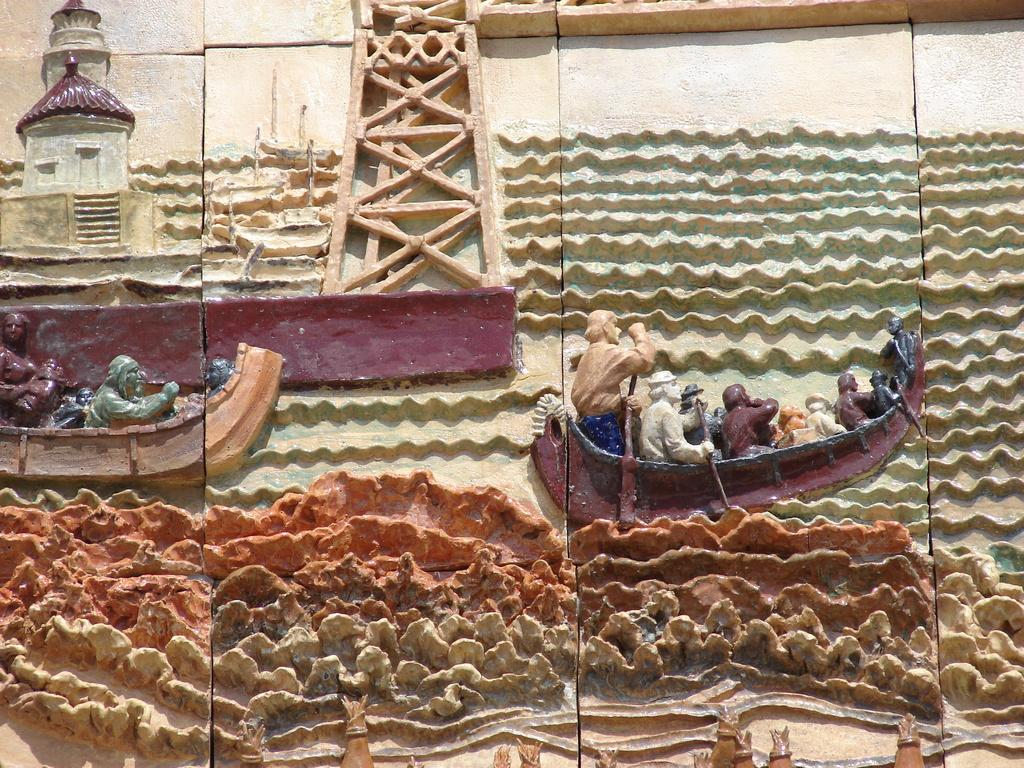Where was the image taken? The image was taken outdoors. What can be seen on the wall in the image? There is a wall with carvings in the image. How many boats are visible in the image? There are two boats in the image. What structure is present in the image? There is a tower in the image. Are there any people in the image? Yes, there are people present in the image. What type of mitten is being used by the people in the image? There are no mittens present in the image; it is taken outdoors, but no one is wearing mittens. 